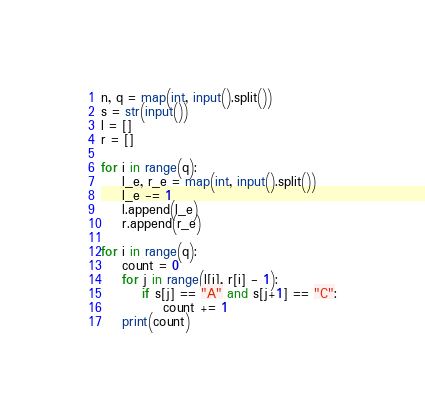Convert code to text. <code><loc_0><loc_0><loc_500><loc_500><_Python_>n, q = map(int, input().split())
s = str(input())
l = []
r = []

for i in range(q):
    l_e, r_e = map(int, input().split())
    l_e -= 1
    l.append(l_e)
    r.append(r_e)

for i in range(q):
    count = 0
    for j in range(l[i], r[i] - 1):
        if s[j] == "A" and s[j+1] == "C":
            count += 1
    print(count)</code> 